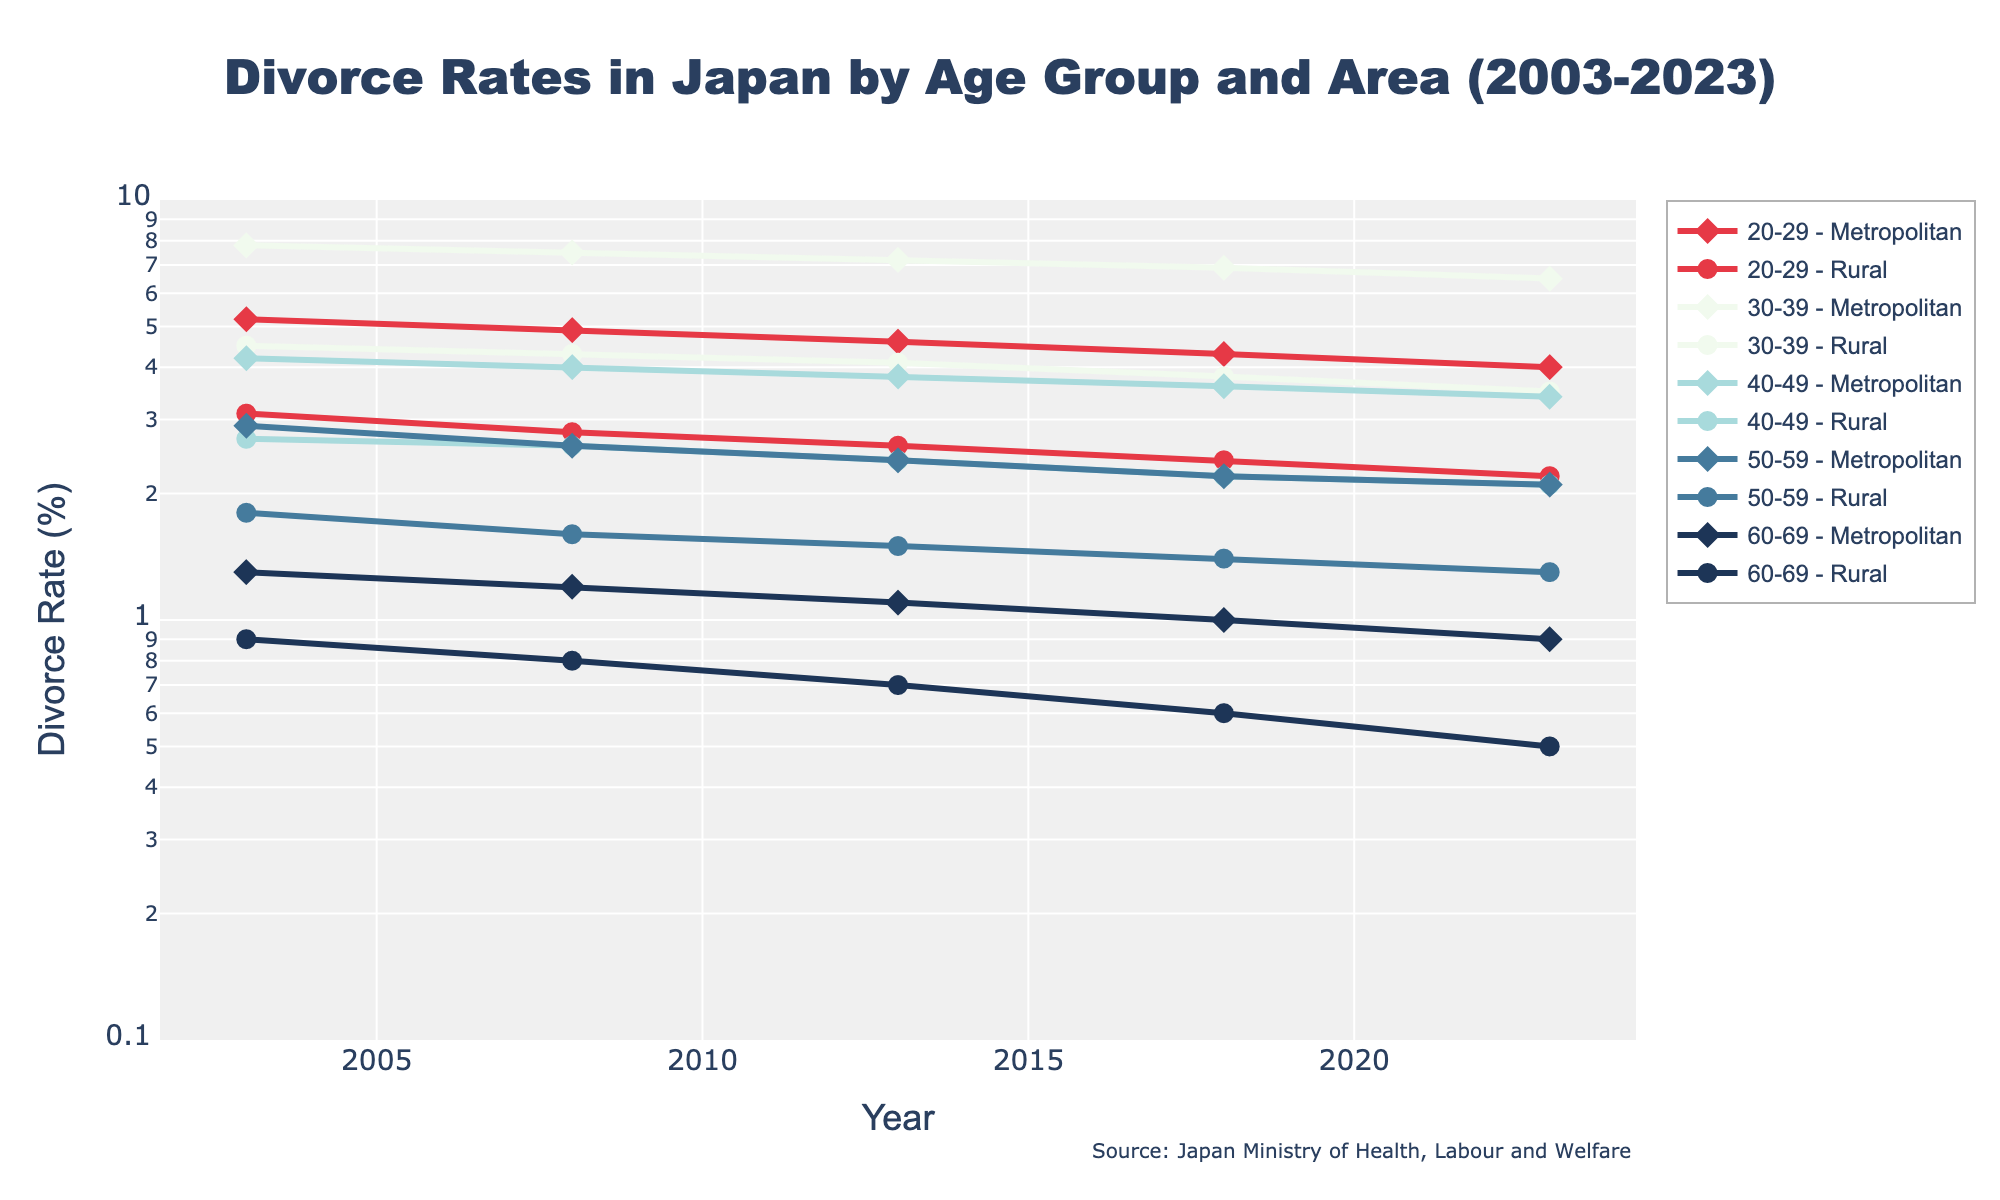What is the title of the figure? The title of the figure is displayed prominently at the top, providing an overview of the visualization. In this case, it is indicated within the data dictionary used to generate the plot.
Answer: Divorce Rates in Japan by Age Group and Area (2003-2023) What is the divorce rate for the 30-39 age group in metropolitan areas in 2023? Locate the 30-39 age group and metropolitan area on the legend, then trace the line to the point corresponding to the year 2023 on the x-axis. The corresponding y-axis value indicates the divorce rate.
Answer: 6.5% How have divorce rates in rural areas for the 40-49 age group changed from 2003 to 2023? Identify the line for the 40-49 age group in rural areas. Compare the starting point (2003) and the ending point (2023) on the x-axis to observe the change in the divorce rates depicted on the y-axis.
Answer: Decreased from 2.7% to 2.1% Which age group had the highest divorce rate in metropolitan areas in 2003? Locate the metropolitan markers for the year 2003. Compare the y-values for each age group; the highest value will indicate the age group with the highest divorce rate.
Answer: 30-39 What trend do you observe for the divorce rates in the 20-29 age group in rural areas from 2003 to 2023? Follow the line for the 20-29 age group in rural areas from 2003 to 2023, noting the change in y-values over time. Observe whether the values are increasing, decreasing, or remaining constant.
Answer: Decreasing What is the difference in divorce rates between metropolitan and rural areas for the 50-59 age group in 2013? Identify the divorce rates for both metropolitan and rural areas for the 50-59 age group in 2013. Subtract the rural rate from the metropolitan rate to find the difference.
Answer: 0.9% Compare the divorce rates of the 30-39 age group in metropolitan areas between 2013 and 2023. Trace the line representing the 30-39 age group in metropolitan areas and compare the y-values at the years 2013 and 2023. Note whether the rate has increased or decreased.
Answer: Decreased from 7.2% to 6.5% Which area (metropolitan or rural) shows a steeper decline in divorce rates for the 40-49 age group over the 20 years? Compare the slopes of the lines representing the 40-49 age group in both metropolitan and rural areas. The steeper decline corresponds to the area with the more significant rate decrease.
Answer: Rural areas What is the minimum divorce rate value observed across all age groups and areas in 2023? Determine the lowest y-value point among all plotted lines for the year 2023. This point represents the minimum divorce rate.
Answer: 0.5% What do you notice about the divorce rates in the 60-69 age group in both metropolitan and rural areas over the 20-year period? Follow the lines for the 60-69 age group in both areas across the years. Note any trends such as increasing, decreasing, or remaining stable for each area.
Answer: Both areas show a decreasing trend 